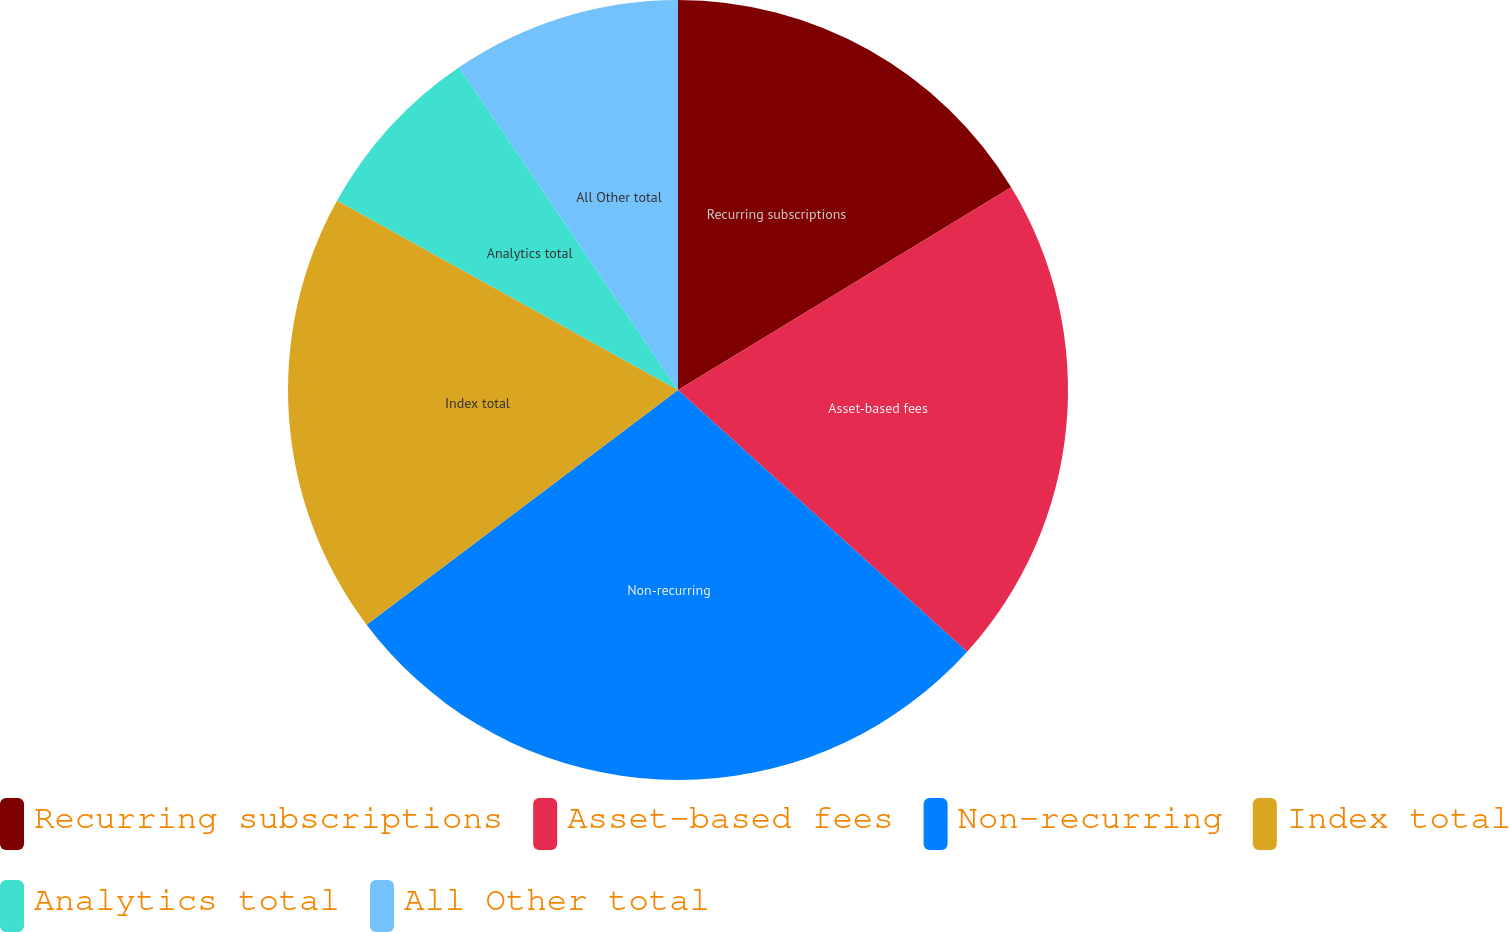<chart> <loc_0><loc_0><loc_500><loc_500><pie_chart><fcel>Recurring subscriptions<fcel>Asset-based fees<fcel>Non-recurring<fcel>Index total<fcel>Analytics total<fcel>All Other total<nl><fcel>16.3%<fcel>20.41%<fcel>28.01%<fcel>18.35%<fcel>7.44%<fcel>9.49%<nl></chart> 